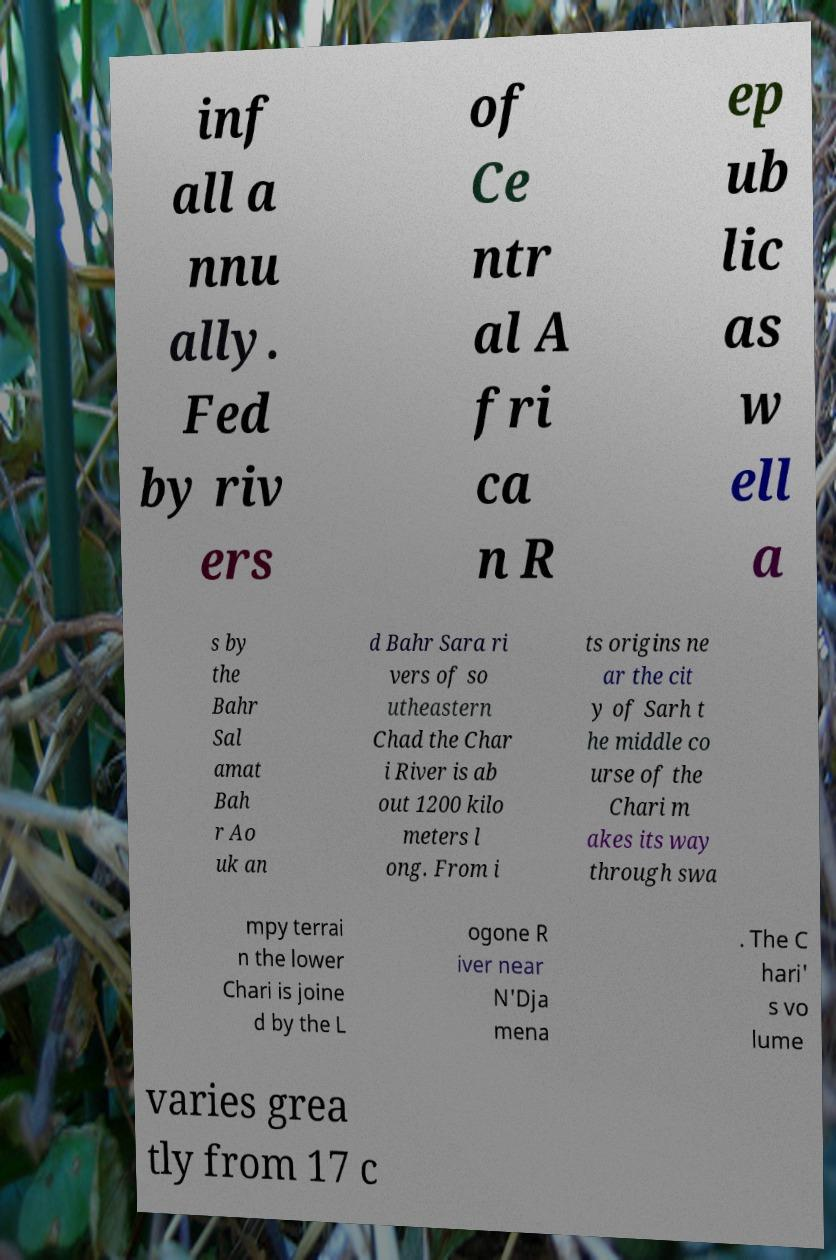Please identify and transcribe the text found in this image. inf all a nnu ally. Fed by riv ers of Ce ntr al A fri ca n R ep ub lic as w ell a s by the Bahr Sal amat Bah r Ao uk an d Bahr Sara ri vers of so utheastern Chad the Char i River is ab out 1200 kilo meters l ong. From i ts origins ne ar the cit y of Sarh t he middle co urse of the Chari m akes its way through swa mpy terrai n the lower Chari is joine d by the L ogone R iver near N'Dja mena . The C hari' s vo lume varies grea tly from 17 c 